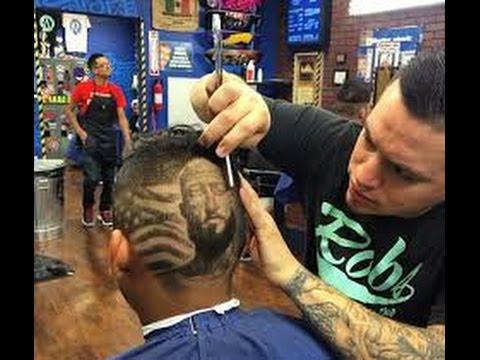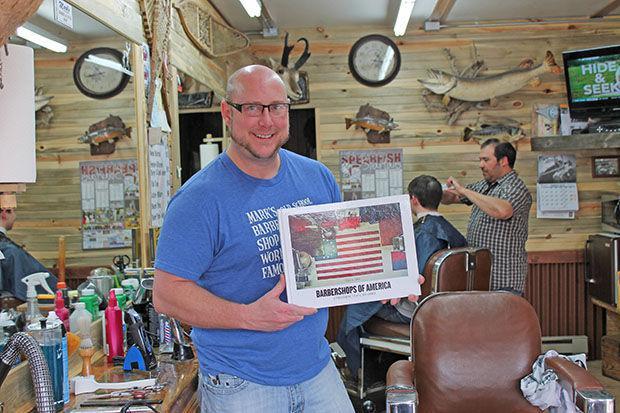The first image is the image on the left, the second image is the image on the right. Given the left and right images, does the statement "In at least one image there is a single man in a suit and tie sitting in a barber chair." hold true? Answer yes or no. No. The first image is the image on the left, the second image is the image on the right. Given the left and right images, does the statement "The left image shows an older black man in suit, tie and eyeglasses, sitting on a white barber chair." hold true? Answer yes or no. No. 